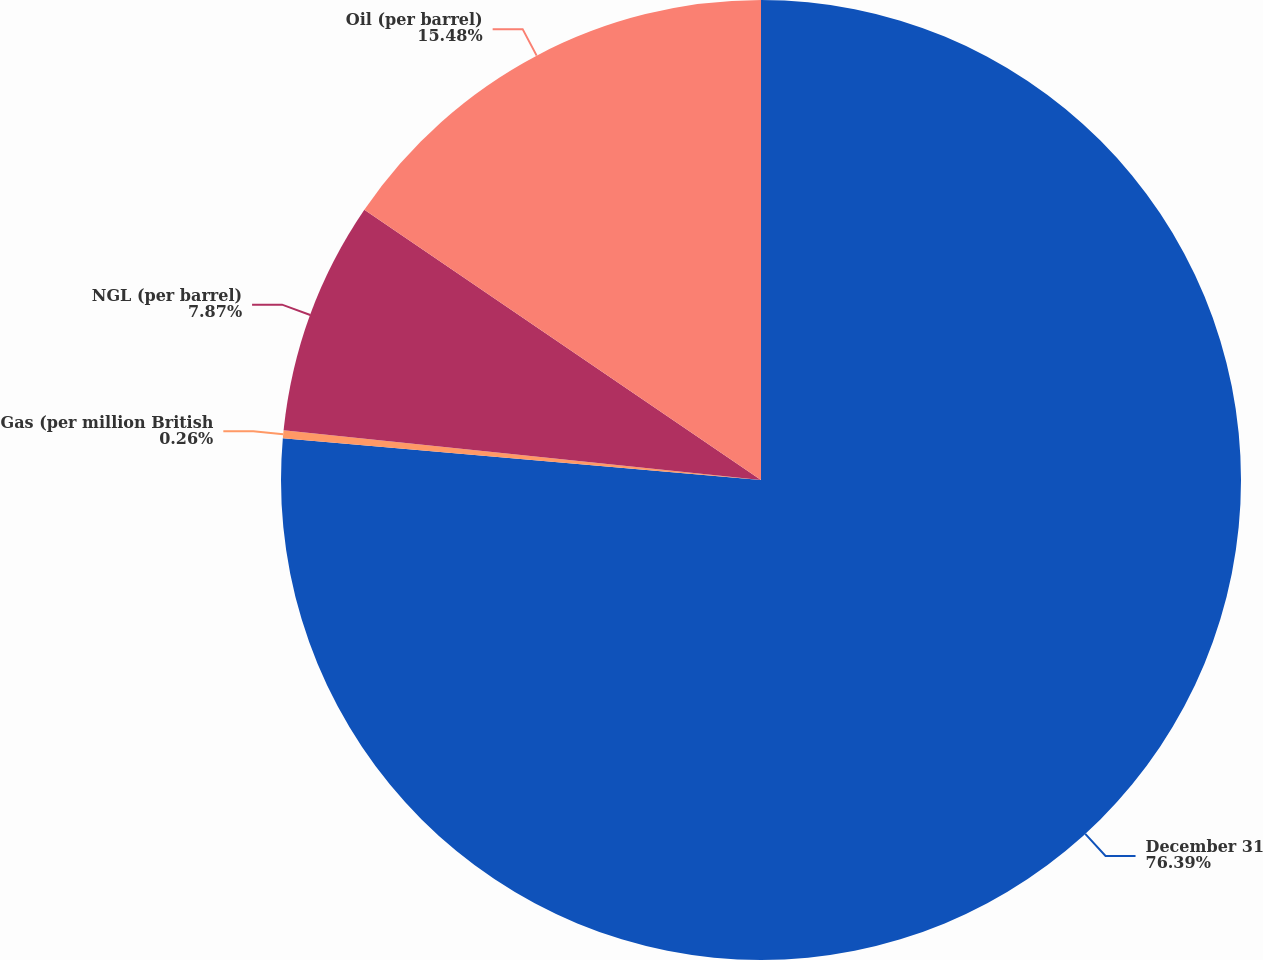Convert chart. <chart><loc_0><loc_0><loc_500><loc_500><pie_chart><fcel>December 31<fcel>Gas (per million British<fcel>NGL (per barrel)<fcel>Oil (per barrel)<nl><fcel>76.39%<fcel>0.26%<fcel>7.87%<fcel>15.48%<nl></chart> 